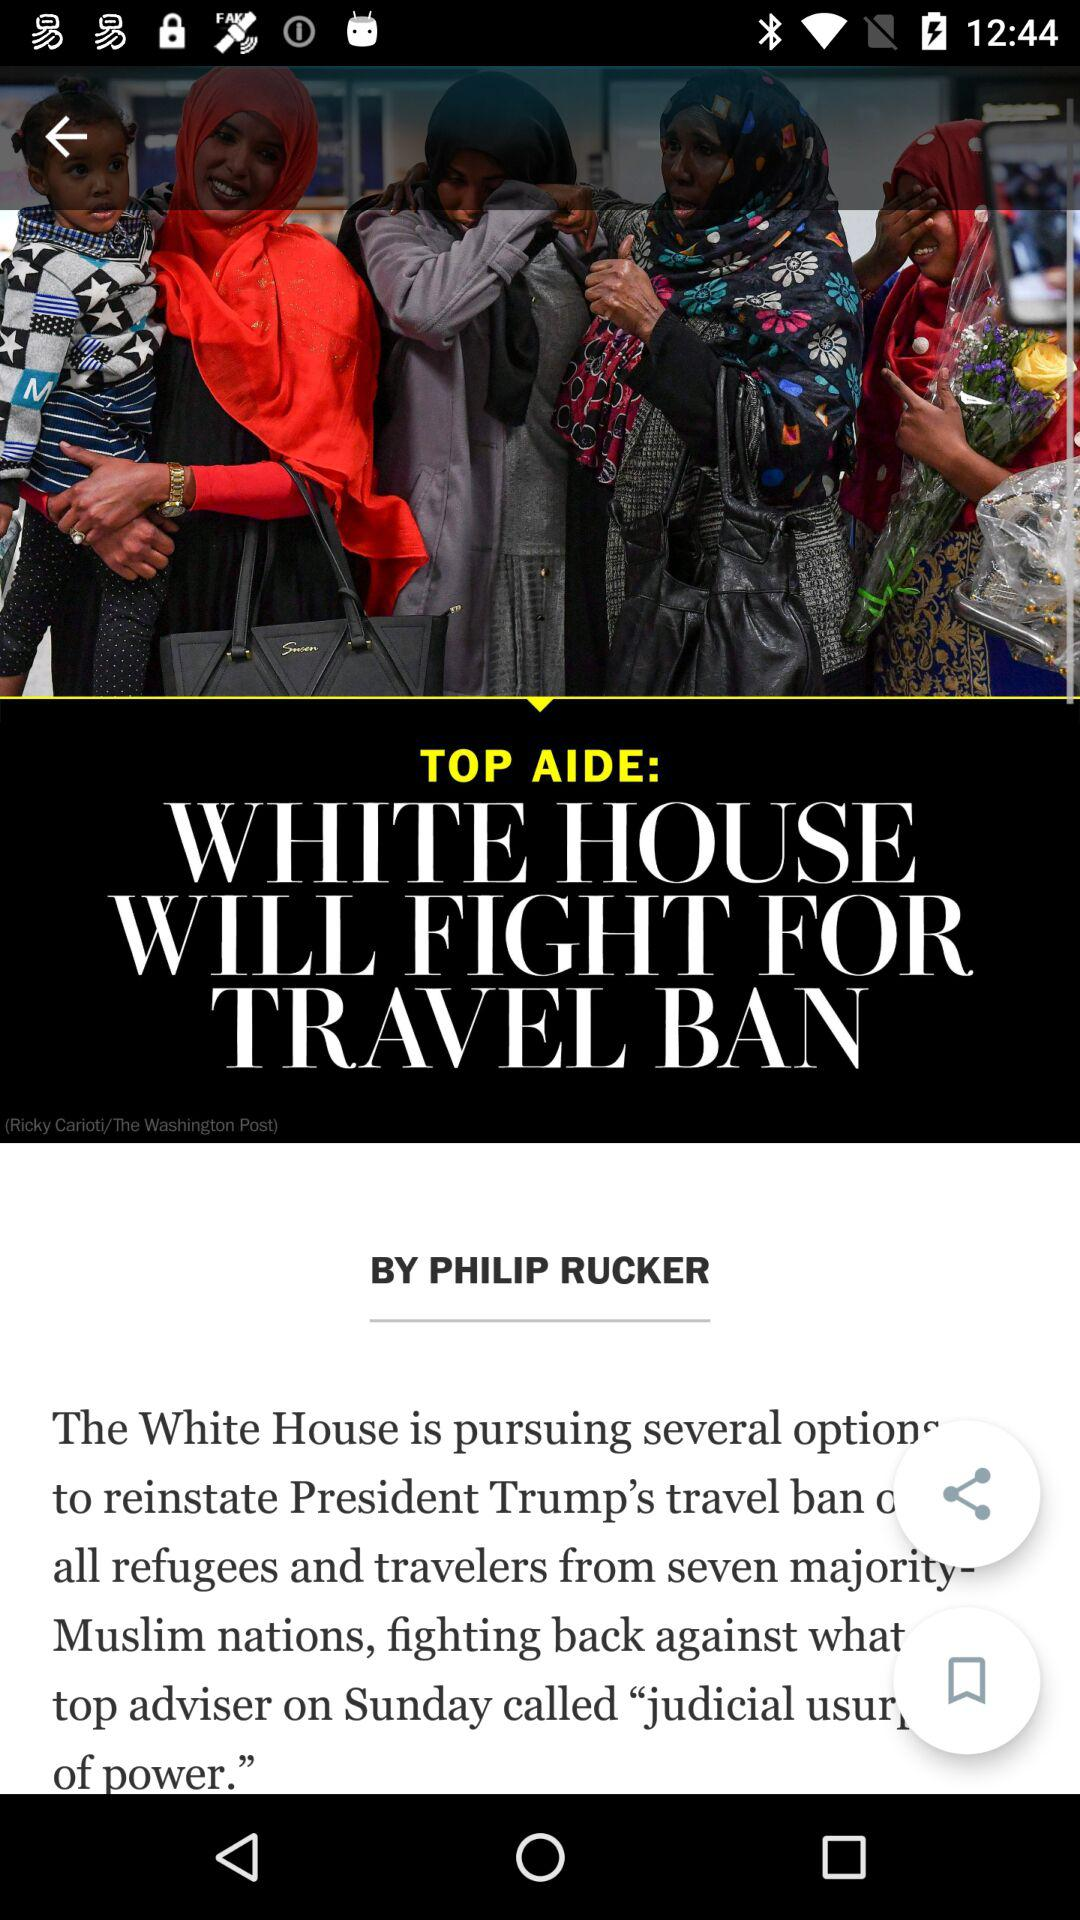What is the headline of the article? The headline of the article is "WHITE HOUSE WILL FIGHT FOR TRAVEL BAN". 